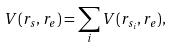<formula> <loc_0><loc_0><loc_500><loc_500>V ( r _ { s } , r _ { e } ) = \sum _ { i } V ( r _ { s _ { i } } , r _ { e } ) ,</formula> 